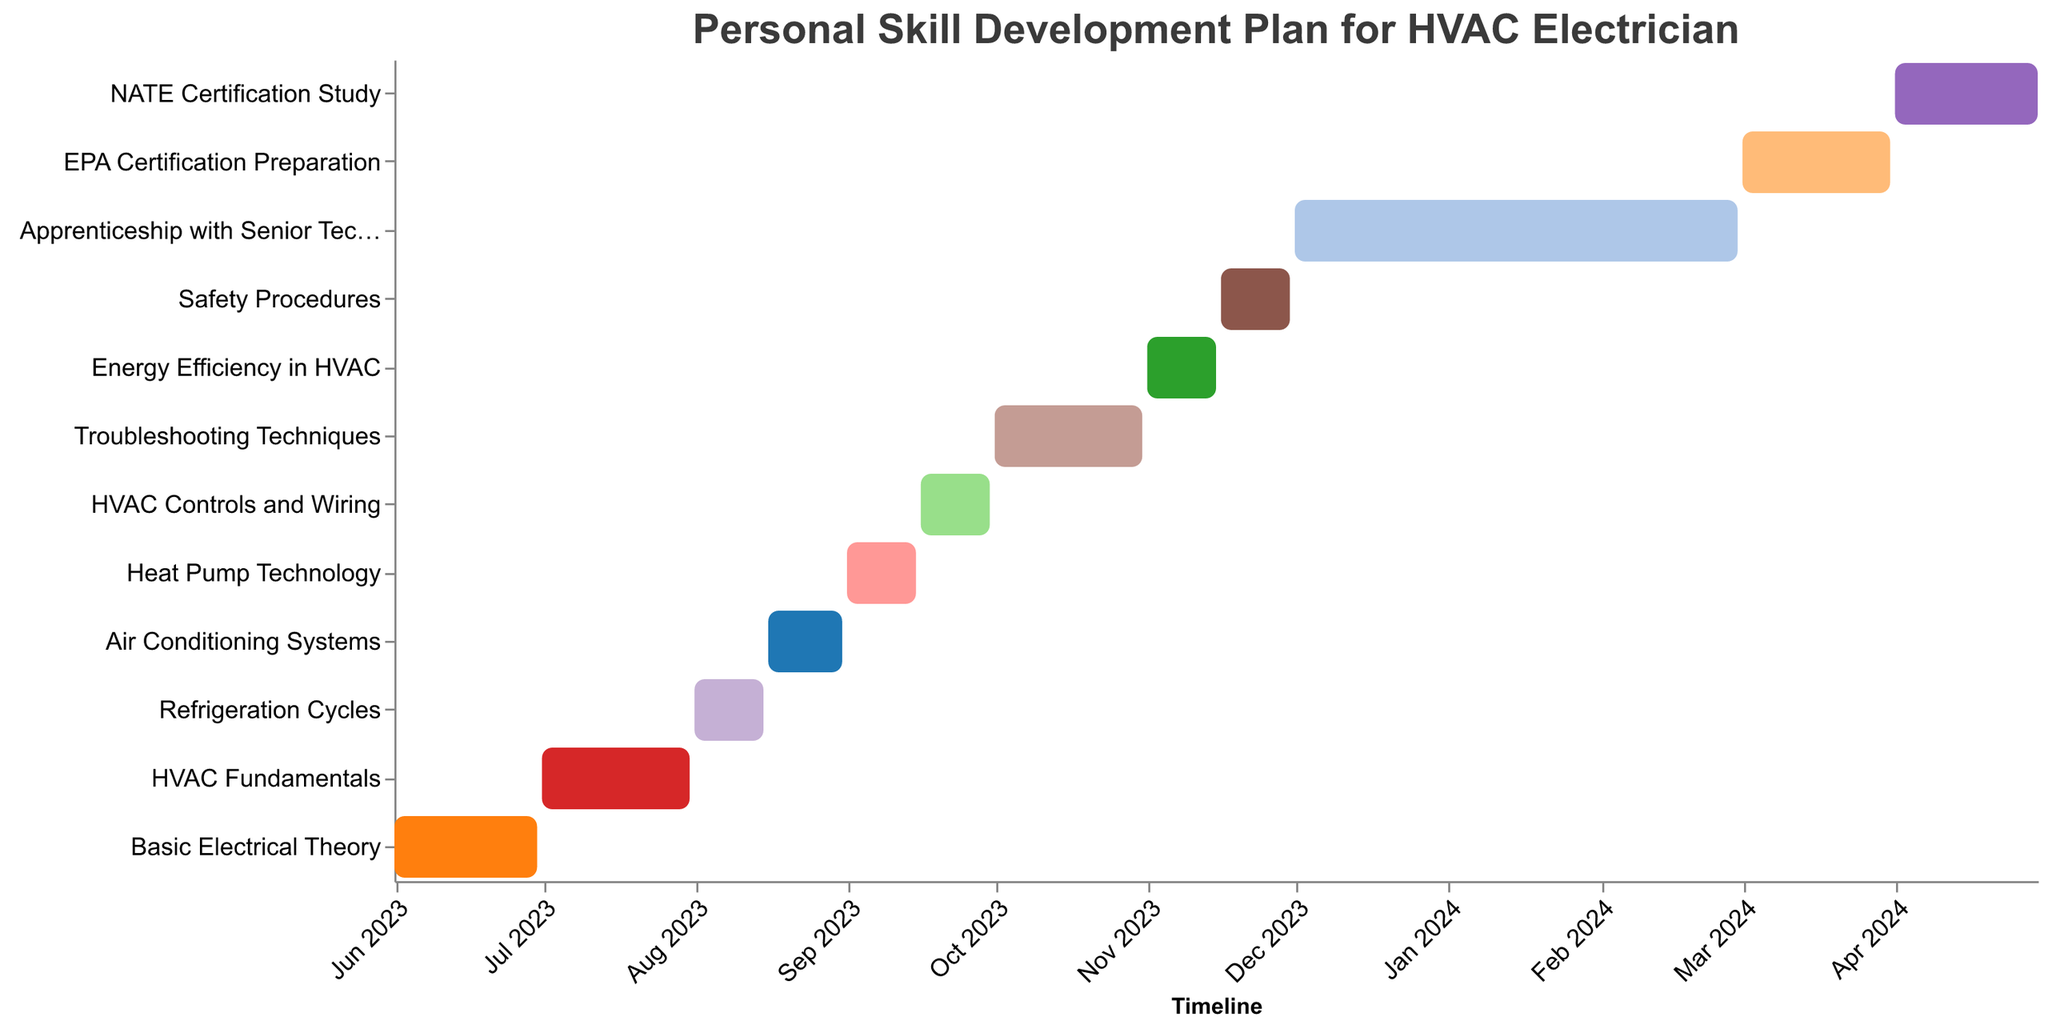What's the title of the chart? The title of the chart is visually prominent at the top and provides a contextual summary of the data.
Answer: Personal Skill Development Plan for HVAC Electrician What is the duration of the "EPA Certification Preparation" task in days? By looking at the bar corresponding to the "EPA Certification Preparation" task and reading off its length on the x-axis, you can see its start and end dates to calculate the duration.
Answer: 31 Which task has the longest duration? By comparing the lengths of all the bars in the chart, the "Apprenticeship with Senior Technician" stands out as the longest.
Answer: Apprenticeship with Senior Technician How many tasks are scheduled to be completed by the end of 2023? Count the number of bars that end before or on December 31, 2023. The tasks are distinct and visually separated by their respective end dates.
Answer: 9 What tasks are scheduled during September 2023? Identify the bars whose timelines intersect with September 2023 on the x-axis. Those are the tasks that fall within that month.
Answer: Heat Pump Technology, HVAC Controls and Wiring How many tasks have a duration of exactly 15 days? Count the number of bars with a duration of 15 days on the y-axis.
Answer: 5 Which task starts immediately after "Refrigeration Cycles"? Look at the earliest starting task right after the end date of "Refrigeration Cycles." This task's bar begins immediately following the end of "Refrigeration Cycles."
Answer: Air Conditioning Systems What's the cumulative duration of all tasks that start in 2024? Sum the durations of tasks that begin in 2024 by identifying their start dates and corresponding durations: “EPA Certification Preparation” (31 days) and “NATE Certification Study” (30 days). Therefore, the sum is 31 + 30 = 61.
Answer: 61 days What is the total number of tasks represented in the chart? Count the number of unique bars in the Gantt chart. Each bar represents a separate task.
Answer: 12 